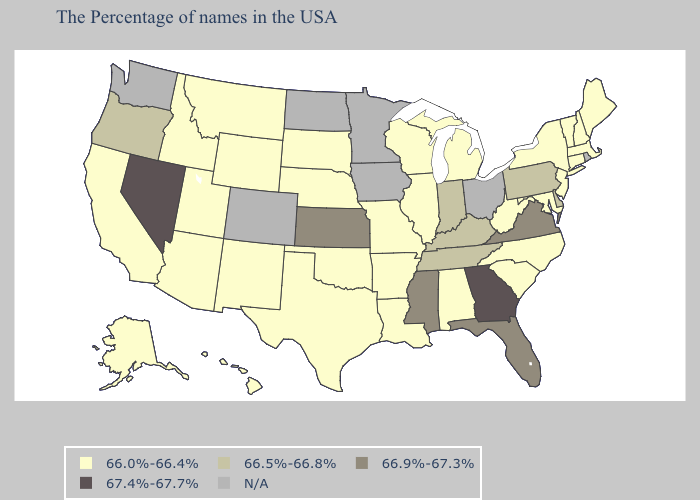Name the states that have a value in the range 67.4%-67.7%?
Short answer required. Georgia, Nevada. Does Virginia have the lowest value in the USA?
Write a very short answer. No. Among the states that border Texas , which have the lowest value?
Keep it brief. Louisiana, Arkansas, Oklahoma, New Mexico. Does the first symbol in the legend represent the smallest category?
Be succinct. Yes. Name the states that have a value in the range N/A?
Short answer required. Rhode Island, Ohio, Minnesota, Iowa, North Dakota, Colorado, Washington. What is the value of Colorado?
Keep it brief. N/A. Name the states that have a value in the range 66.9%-67.3%?
Give a very brief answer. Virginia, Florida, Mississippi, Kansas. What is the lowest value in states that border North Carolina?
Be succinct. 66.0%-66.4%. What is the value of Massachusetts?
Quick response, please. 66.0%-66.4%. Name the states that have a value in the range 67.4%-67.7%?
Concise answer only. Georgia, Nevada. Among the states that border Alabama , does Tennessee have the lowest value?
Write a very short answer. Yes. Name the states that have a value in the range 66.9%-67.3%?
Be succinct. Virginia, Florida, Mississippi, Kansas. What is the value of South Carolina?
Short answer required. 66.0%-66.4%. Name the states that have a value in the range 67.4%-67.7%?
Be succinct. Georgia, Nevada. Among the states that border Pennsylvania , does Delaware have the lowest value?
Answer briefly. No. 